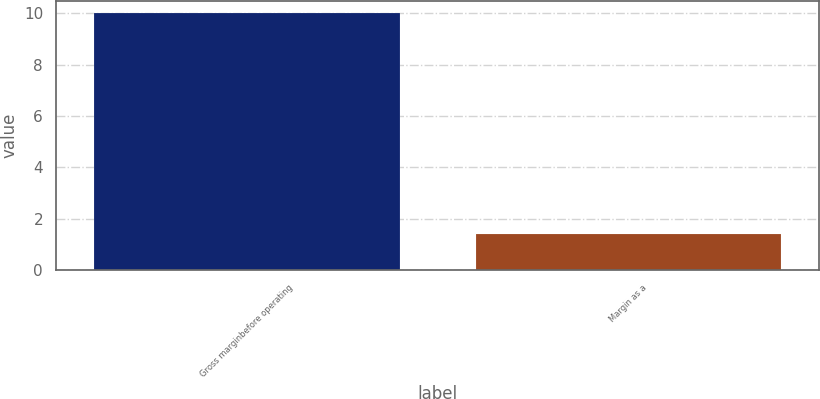Convert chart to OTSL. <chart><loc_0><loc_0><loc_500><loc_500><bar_chart><fcel>Gross marginbefore operating<fcel>Margin as a<nl><fcel>10<fcel>1.4<nl></chart> 